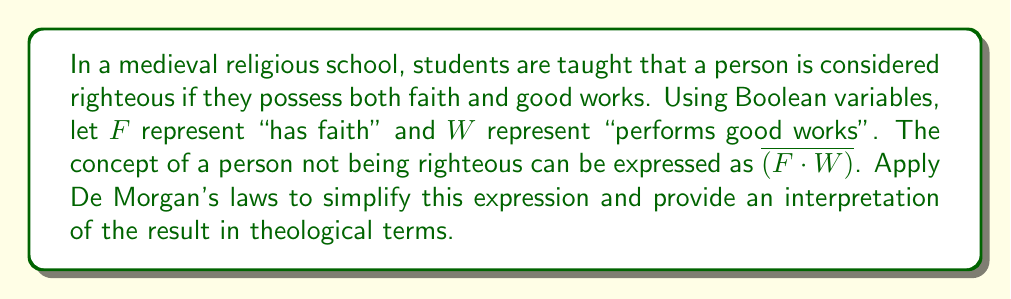Solve this math problem. Let's approach this step-by-step:

1) We start with the expression $\overline{(F \cdot W)}$, which represents "not (faith and good works)".

2) Applying De Morgan's first law, we can transform this expression:
   $\overline{(F \cdot W)} = \overline{F} + \overline{W}$

3) This simplified expression can be interpreted as:
   "Either not having faith OR not performing good works"

4) In theological terms, this means that a person is not righteous if they lack faith or if they lack good works (or both).

5) This aligns with the medieval Christian doctrine that both faith and works are necessary for righteousness. The absence of either is sufficient to negate righteousness.

6) It's worth noting that this Boolean representation simplifies a complex theological concept. In reality, faith and works were often seen as interrelated, with true faith naturally leading to good works.
Answer: $\overline{(F \cdot W)} = \overline{F} + \overline{W}$ 